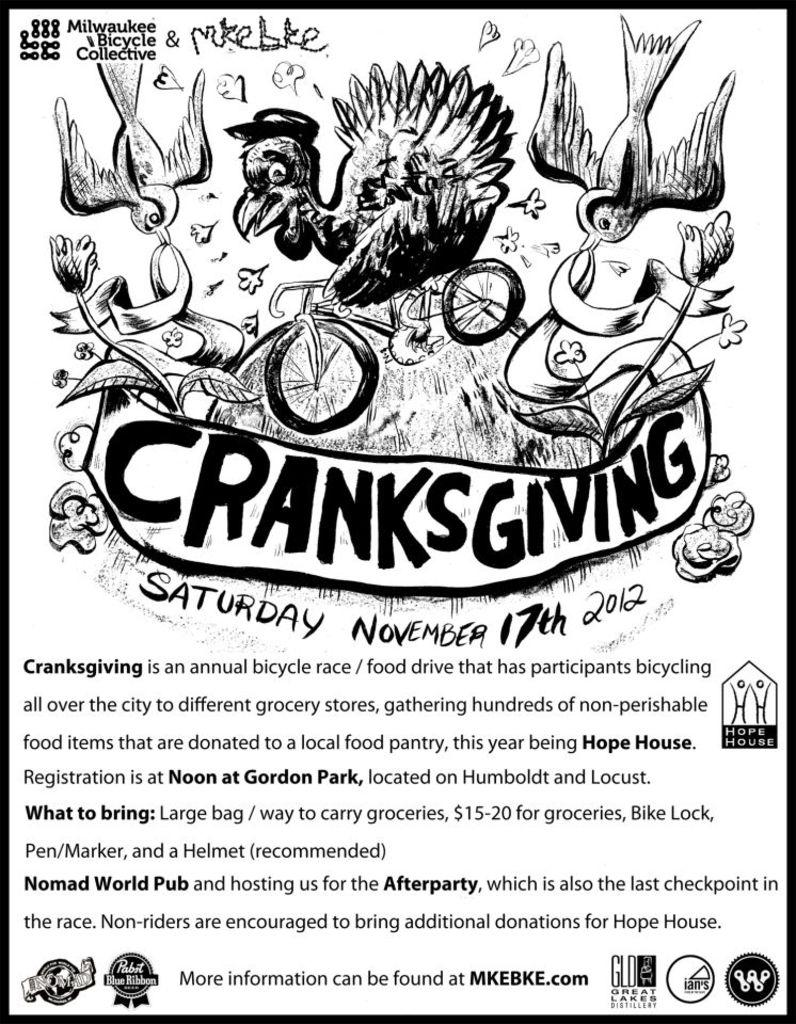Provide a one-sentence caption for the provided image. A black and white flyer advertises a bicycle race called Cranksgiving. 